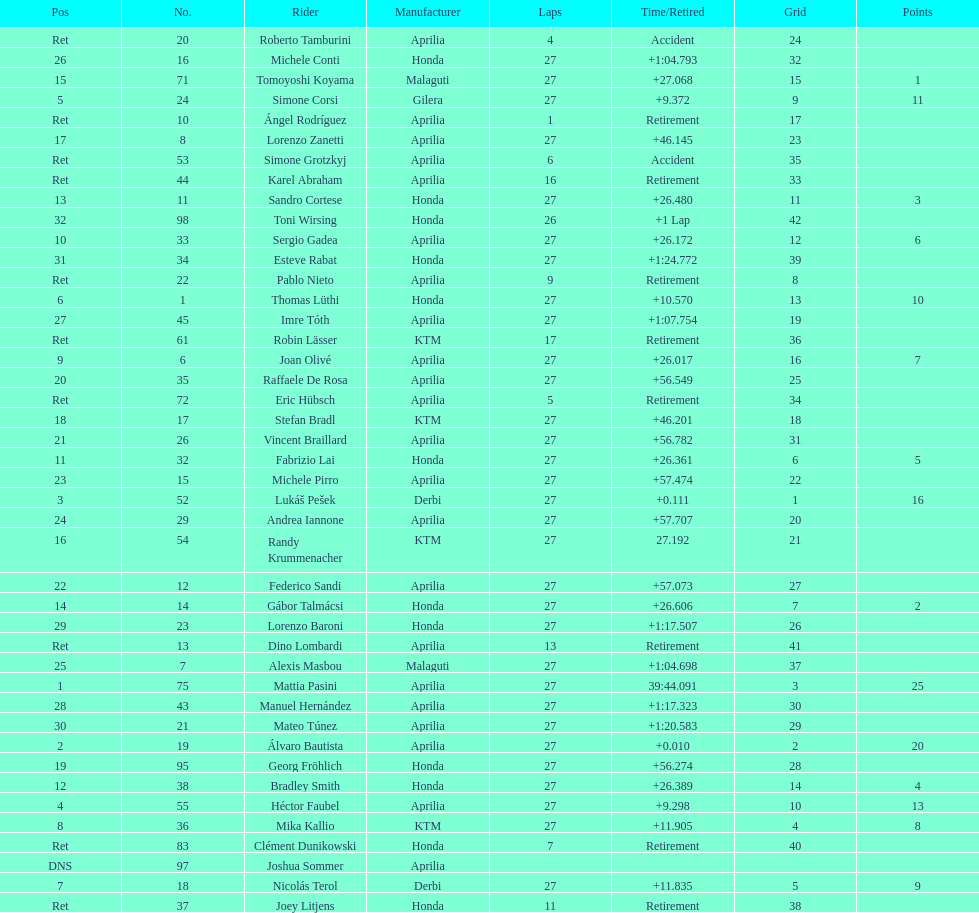Name a racer that had at least 20 points. Mattia Pasini. 